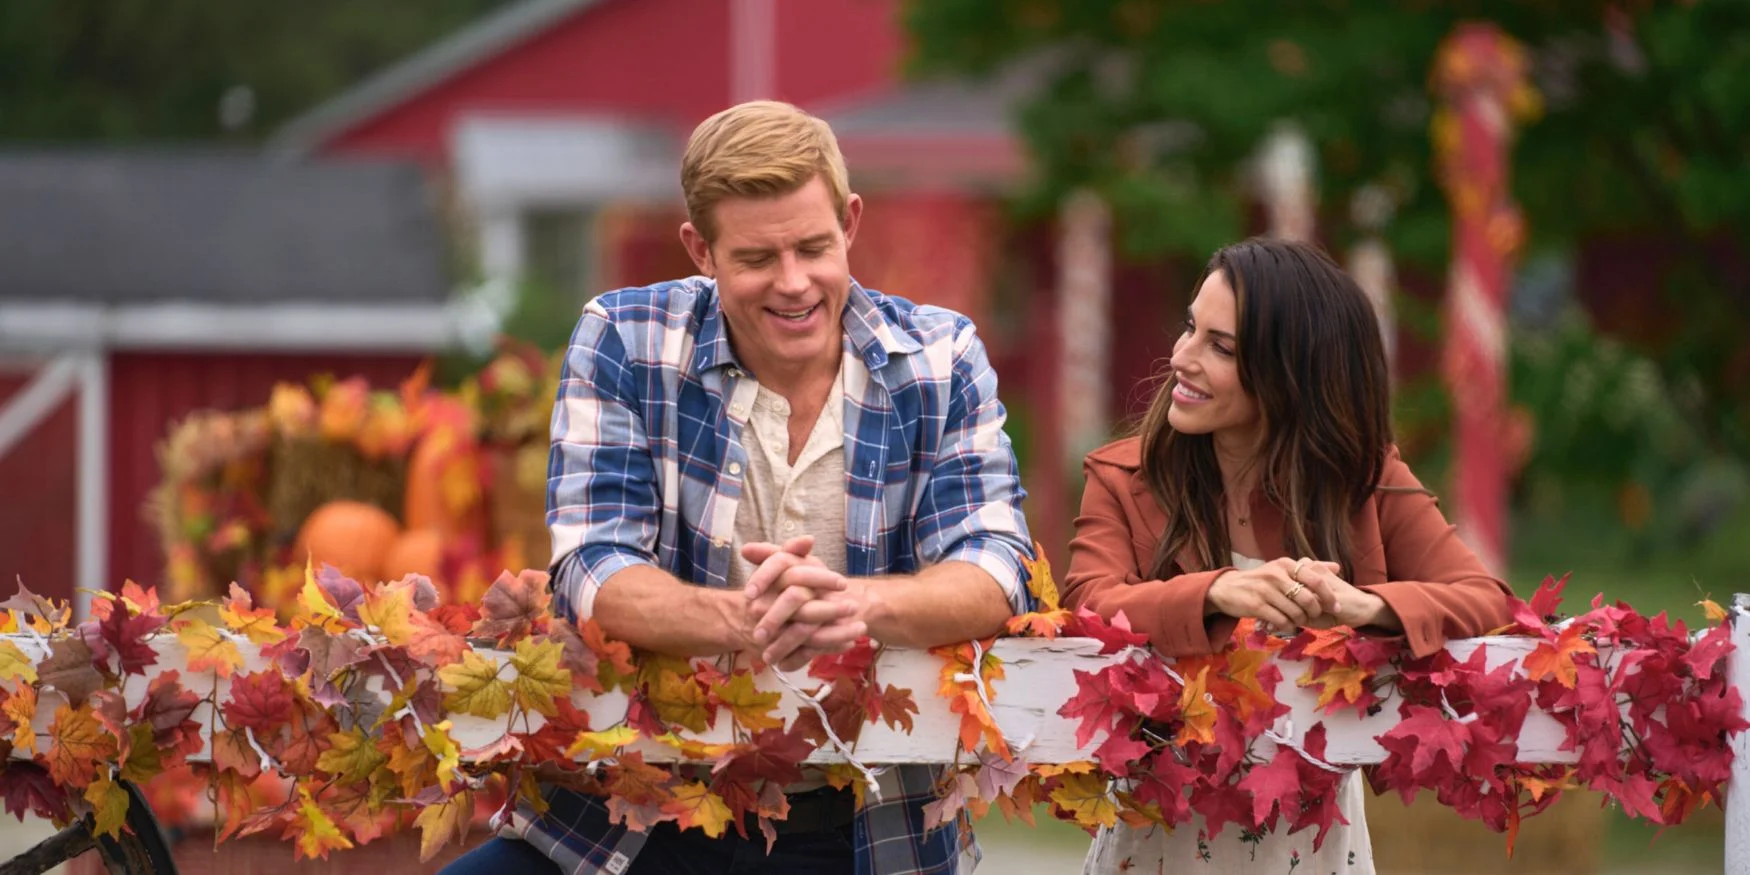Create an imaginative story involving the red barn in the background. The old red barn, nestled on the edge of the enchanting autumn forest, wasn’t just any ordinary barn. Legend had it that this barn was a portal to a mystical world, revealed only to those with the purest of hearts. Generations ago, an ancient witch cast a spell on the barn, linking it to her magical realm, where time stood still in eternal autumn. The leaves stayed perpetually vibrant, and the air was filled with the sweet scent of harvest. Every hundred years, the portal would open, allowing chosen individuals to enter and fulfill a quest to bring back a magical artifact known as the Heart of Seasons, a gem that ensured Earth's yearly seasonal changes. Only when both Trevor and Jana, descendants of the first guardians, unwittingly lean against the enchanted fence while sharing a heartfelt conversation, does a hidden door creak open, beckoning them into a world brimming with magic, mystery, and adventure. Together, they must navigate this wondrous land, face unforeseen challenges, and ultimately retrieve the Heart of Seasons to maintain the balance between worlds. 